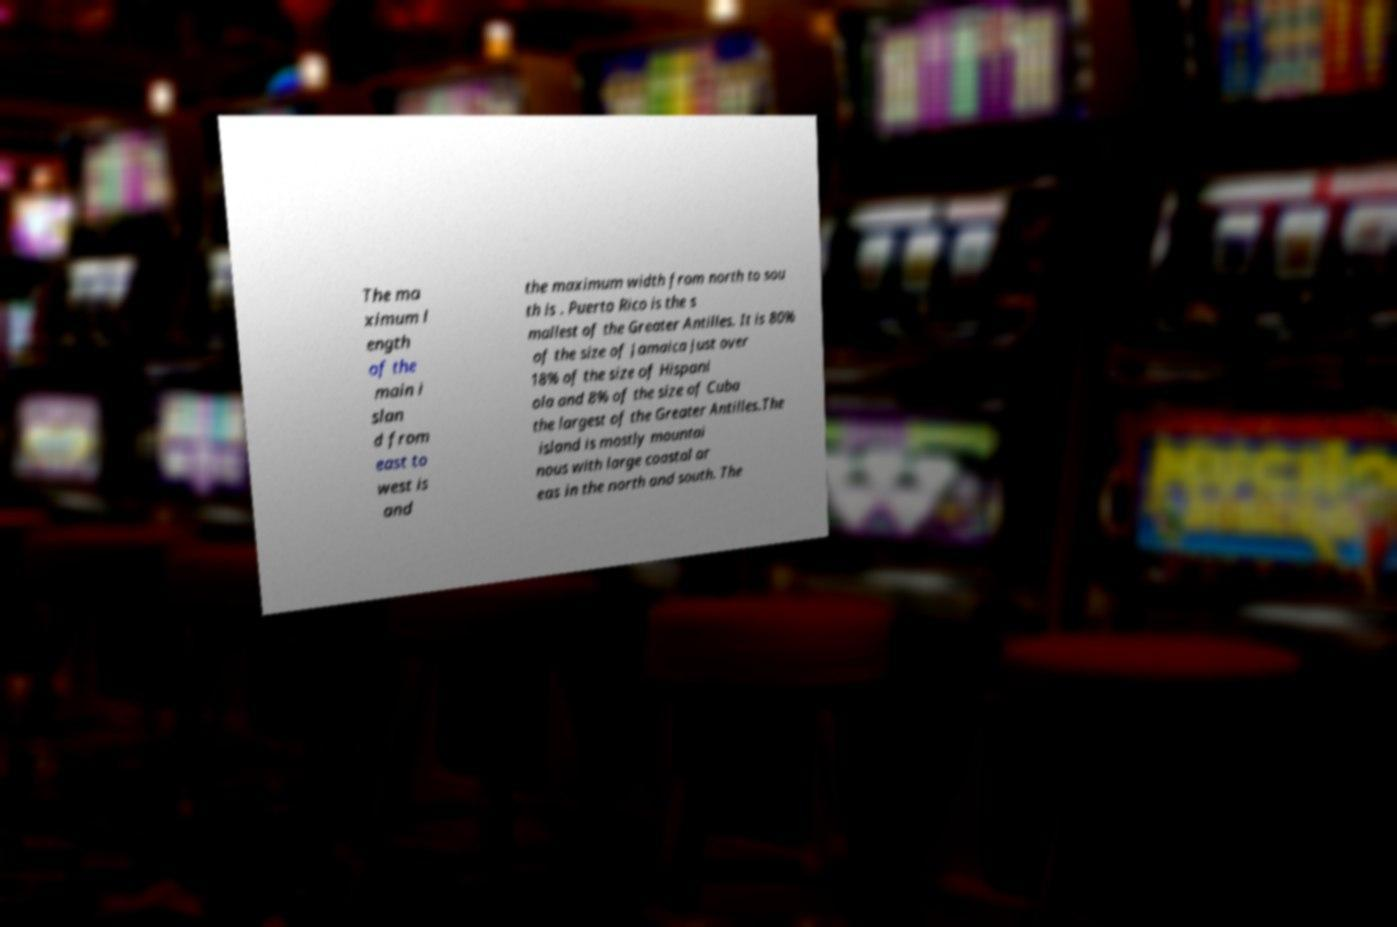I need the written content from this picture converted into text. Can you do that? The ma ximum l ength of the main i slan d from east to west is and the maximum width from north to sou th is . Puerto Rico is the s mallest of the Greater Antilles. It is 80% of the size of Jamaica just over 18% of the size of Hispani ola and 8% of the size of Cuba the largest of the Greater Antilles.The island is mostly mountai nous with large coastal ar eas in the north and south. The 